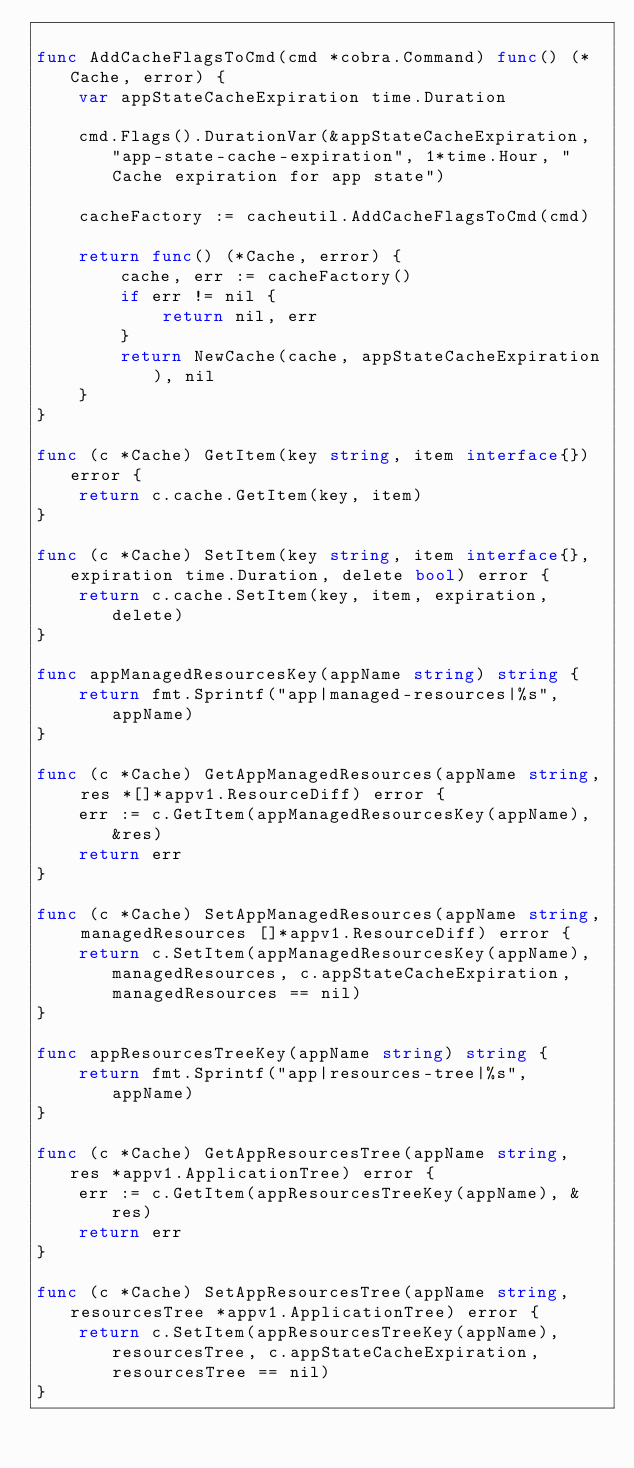<code> <loc_0><loc_0><loc_500><loc_500><_Go_>
func AddCacheFlagsToCmd(cmd *cobra.Command) func() (*Cache, error) {
	var appStateCacheExpiration time.Duration

	cmd.Flags().DurationVar(&appStateCacheExpiration, "app-state-cache-expiration", 1*time.Hour, "Cache expiration for app state")

	cacheFactory := cacheutil.AddCacheFlagsToCmd(cmd)

	return func() (*Cache, error) {
		cache, err := cacheFactory()
		if err != nil {
			return nil, err
		}
		return NewCache(cache, appStateCacheExpiration), nil
	}
}

func (c *Cache) GetItem(key string, item interface{}) error {
	return c.cache.GetItem(key, item)
}

func (c *Cache) SetItem(key string, item interface{}, expiration time.Duration, delete bool) error {
	return c.cache.SetItem(key, item, expiration, delete)
}

func appManagedResourcesKey(appName string) string {
	return fmt.Sprintf("app|managed-resources|%s", appName)
}

func (c *Cache) GetAppManagedResources(appName string, res *[]*appv1.ResourceDiff) error {
	err := c.GetItem(appManagedResourcesKey(appName), &res)
	return err
}

func (c *Cache) SetAppManagedResources(appName string, managedResources []*appv1.ResourceDiff) error {
	return c.SetItem(appManagedResourcesKey(appName), managedResources, c.appStateCacheExpiration, managedResources == nil)
}

func appResourcesTreeKey(appName string) string {
	return fmt.Sprintf("app|resources-tree|%s", appName)
}

func (c *Cache) GetAppResourcesTree(appName string, res *appv1.ApplicationTree) error {
	err := c.GetItem(appResourcesTreeKey(appName), &res)
	return err
}

func (c *Cache) SetAppResourcesTree(appName string, resourcesTree *appv1.ApplicationTree) error {
	return c.SetItem(appResourcesTreeKey(appName), resourcesTree, c.appStateCacheExpiration, resourcesTree == nil)
}
</code> 